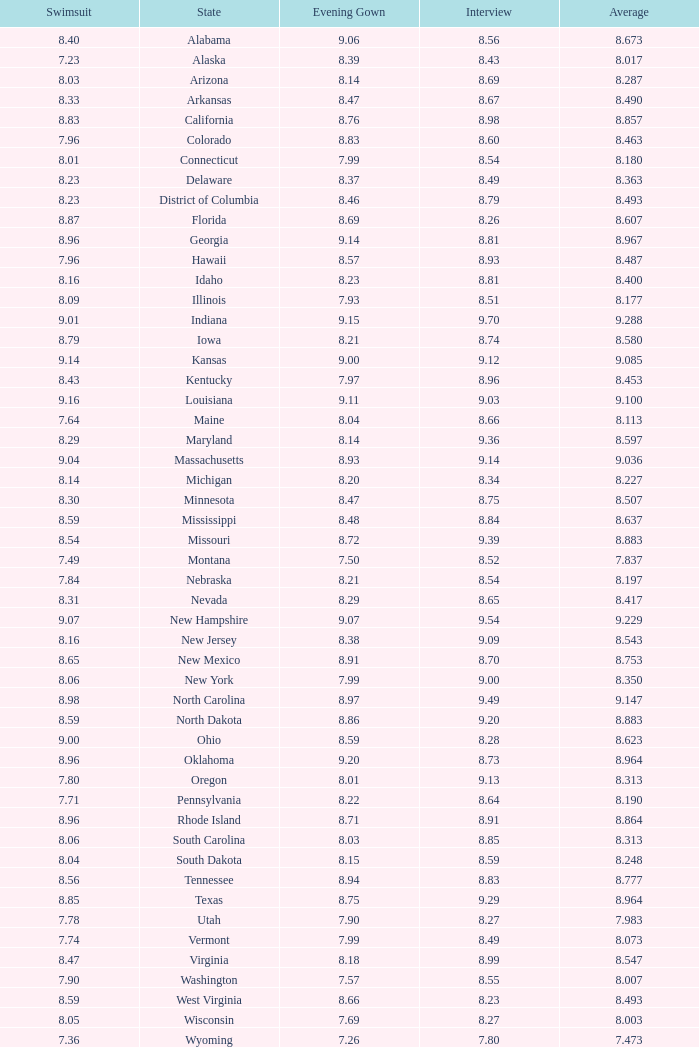Name the state with an evening gown more than 8.86 and interview less than 8.7 and swimsuit less than 8.96 Alabama. 